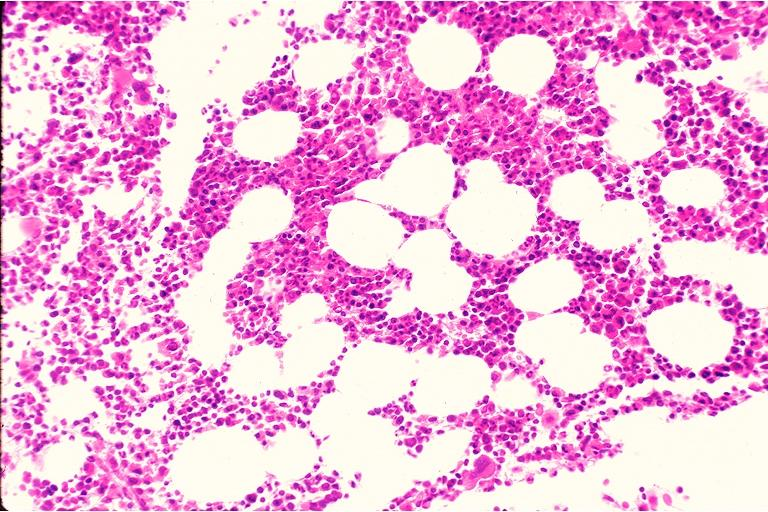s subependymal giant cell astrocytoma present?
Answer the question using a single word or phrase. No 